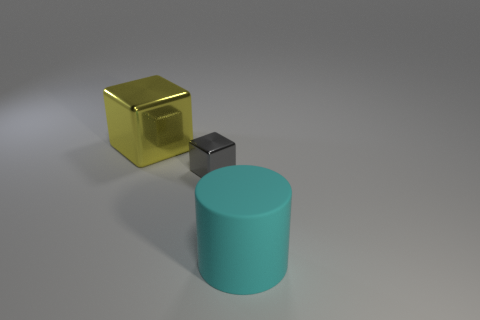Does the large thing that is behind the cyan matte object have the same shape as the object that is right of the small metal thing?
Offer a terse response. No. There is a metallic thing that is in front of the large yellow metal block that is left of the gray shiny thing; what shape is it?
Your response must be concise. Cube. There is a thing that is on the right side of the large yellow metallic thing and on the left side of the large cyan cylinder; what size is it?
Ensure brevity in your answer.  Small. There is a yellow thing; does it have the same shape as the big thing in front of the yellow block?
Your response must be concise. No. What is the size of the yellow thing that is the same shape as the gray thing?
Offer a very short reply. Large. There is a large rubber cylinder; is it the same color as the shiny thing to the left of the gray block?
Provide a short and direct response. No. What number of other things are there of the same size as the cyan matte cylinder?
Make the answer very short. 1. What is the shape of the shiny thing that is in front of the big object that is to the left of the thing in front of the small gray metallic cube?
Provide a short and direct response. Cube. Is the size of the yellow metal thing the same as the block that is in front of the big yellow metal thing?
Your response must be concise. No. What color is the object that is to the right of the large shiny thing and on the left side of the large matte thing?
Make the answer very short. Gray. 